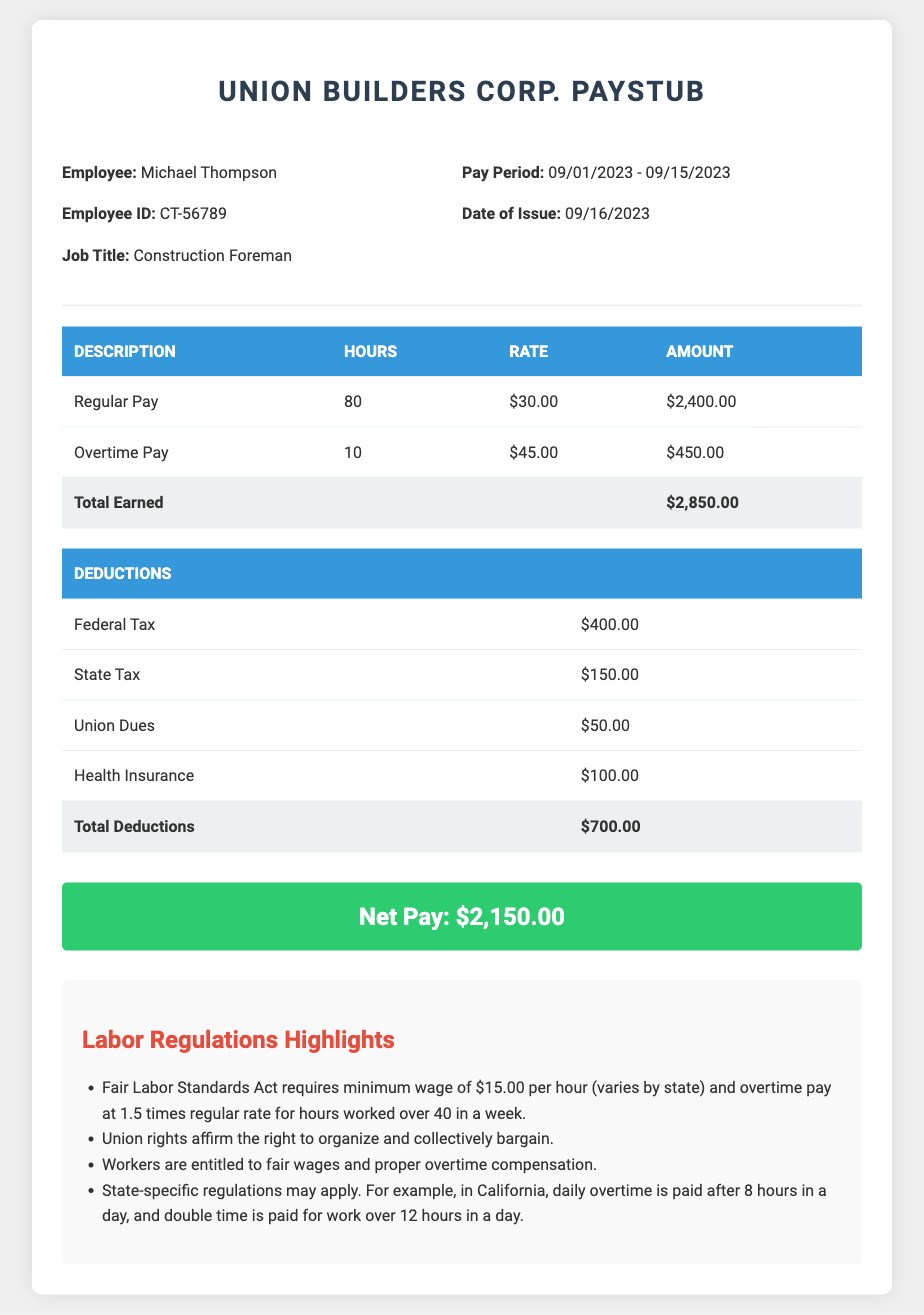What is the employee's name? The employee's name is listed in the employee information section of the paystub.
Answer: Michael Thompson What is the employee's job title? The job title can be found in the employee information section.
Answer: Construction Foreman What is the pay period for this paystub? The pay period is indicated in the pay information section of the document.
Answer: 09/01/2023 - 09/15/2023 How many hours of overtime did the employee work? The number of overtime hours is specified in the earnings table of the paystub.
Answer: 10 What is the total earned before deductions? The total earned is displayed in the total row of the earnings table in the document.
Answer: $2,850.00 What is the total amount of deductions? The total deductions can be found in the total row of the deductions table.
Answer: $700.00 What is the net pay for this pay period? The net pay is prominently displayed at the end of the paystub.
Answer: $2,150.00 What is the minimum wage requirement under the Fair Labor Standards Act? The specific regulation is mentioned in the labor regulations section of the document.
Answer: $15.00 per hour What is the overtime pay rate for this employee? The overtime pay rate is detailed in the earnings table of the paystub.
Answer: $45.00 What union dues were deducted? The amount deducted for union dues is specified among the deductions.
Answer: $50.00 